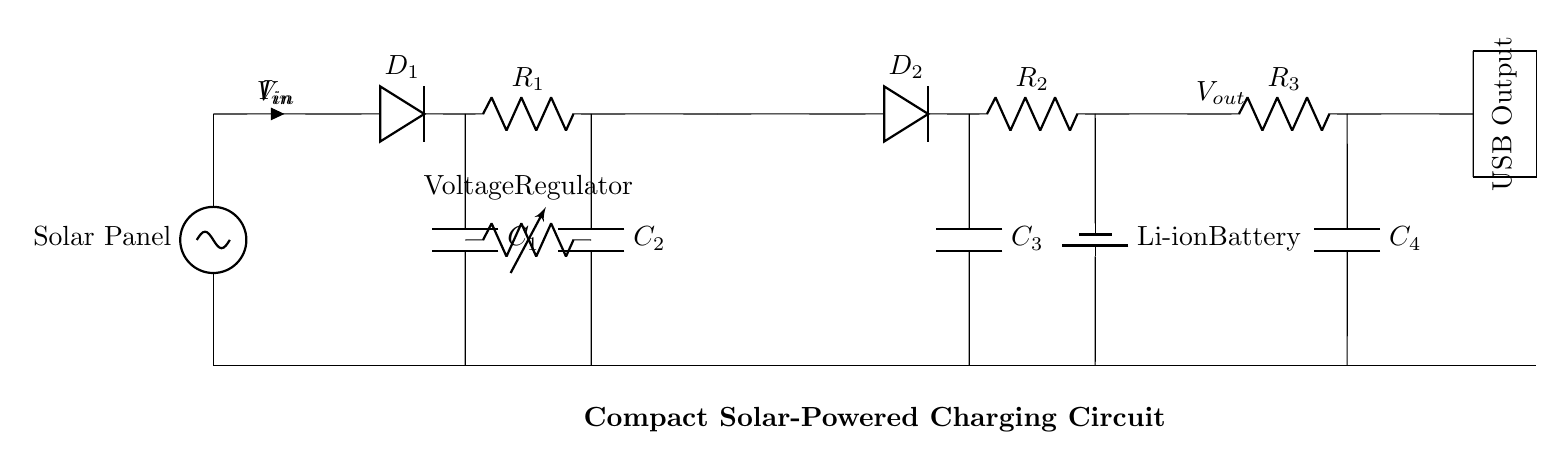What is the function of the solar panel in this circuit? The solar panel converts sunlight into electrical energy, providing the initial input voltage for the circuit.
Answer: Converts sunlight to electricity What components are used for voltage regulation? The components for voltage regulation are the voltage regulator and the capacitors C1 and C2, which help stabilize the output voltage.
Answer: Voltage regulator, C1, C2 How many capacitors are present in this circuit? There are four capacitors labeled C1, C2, C3, and C4, which are used for various filtering and stabilization purposes.
Answer: Four What type of battery is used in this circuit? The circuit contains a Li-ion battery, which is commonly used for energy storage in mobile devices.
Answer: Li-ion battery What is the purpose of diode D2? Diode D2 allows current to flow in one direction, preventing the battery from discharging back into the charging circuit when not connected to the solar panel.
Answer: Prevents battery discharge What happens to the voltage output when the solar panel is shaded? When the solar panel is shaded, the voltage output decreases due to reduced sunlight, which leads to lower energy conversion efficiency.
Answer: Voltage output decreases How is the USB output generated in this circuit? The USB output is generated after the voltage has been stepped down and regulated through components R3 and C4, supplying power to connected devices.
Answer: R3 and C4 regulate the output 